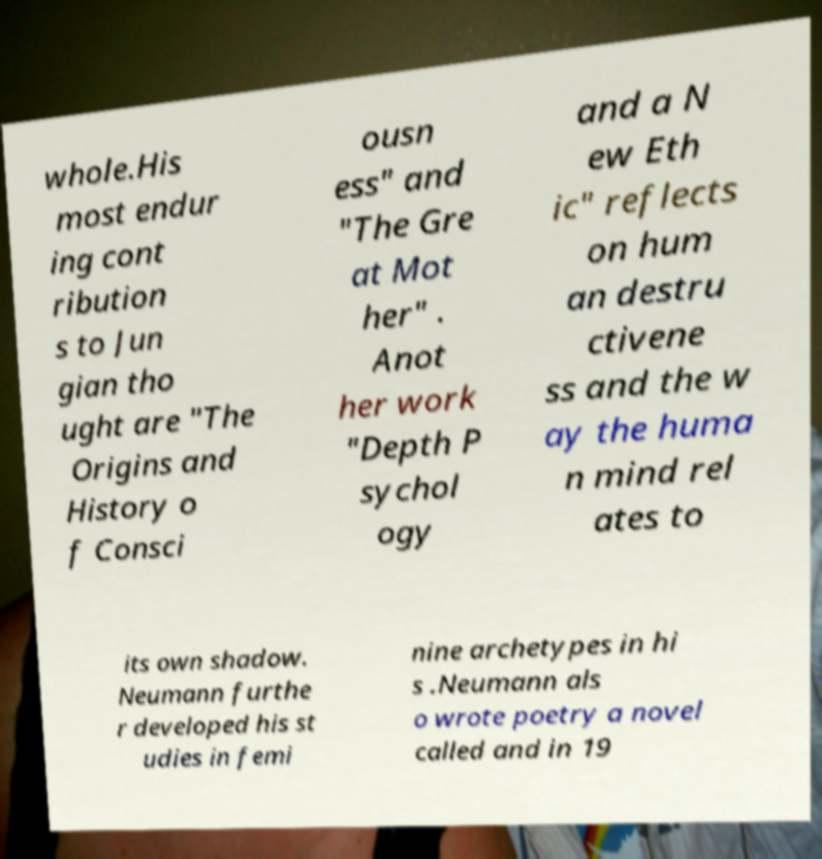Can you accurately transcribe the text from the provided image for me? whole.His most endur ing cont ribution s to Jun gian tho ught are "The Origins and History o f Consci ousn ess" and "The Gre at Mot her" . Anot her work "Depth P sychol ogy and a N ew Eth ic" reflects on hum an destru ctivene ss and the w ay the huma n mind rel ates to its own shadow. Neumann furthe r developed his st udies in femi nine archetypes in hi s .Neumann als o wrote poetry a novel called and in 19 